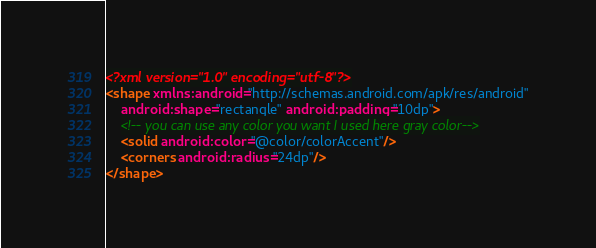Convert code to text. <code><loc_0><loc_0><loc_500><loc_500><_XML_><?xml version="1.0" encoding="utf-8"?>
<shape xmlns:android="http://schemas.android.com/apk/res/android"
    android:shape="rectangle" android:padding="10dp">
    <!-- you can use any color you want I used here gray color-->
    <solid android:color="@color/colorAccent"/>
    <corners android:radius="24dp"/>
</shape></code> 